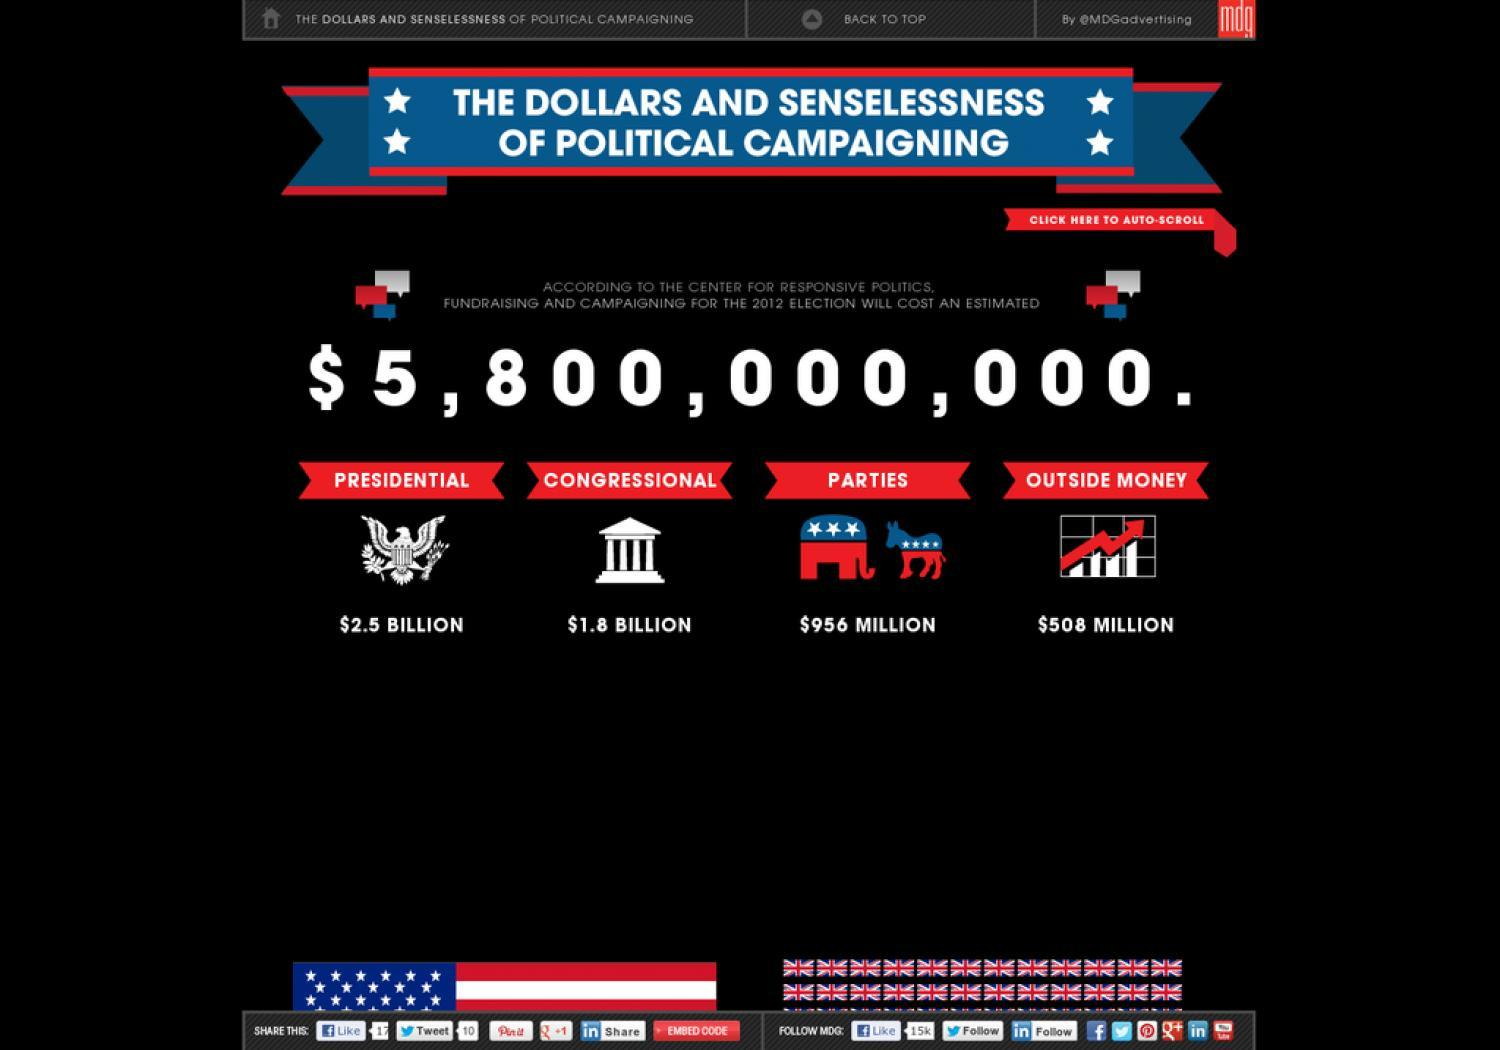how much of money is spent by parties
Answer the question with a short phrase. $956 million How much of outside money will be spent on campaigning $508 million Where is money spent in billions presidential, congressional 